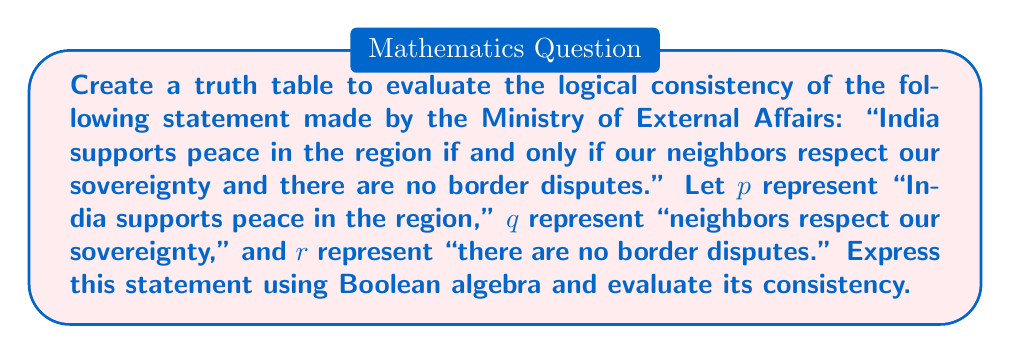Could you help me with this problem? 1. First, let's express the statement using Boolean algebra:
   $p \leftrightarrow (q \land r)$

2. To create a truth table, we need to consider all possible combinations of truth values for $p$, $q$, and $r$. There are $2^3 = 8$ possible combinations.

3. Let's create the truth table:

   | $p$ | $q$ | $r$ | $q \land r$ | $p \leftrightarrow (q \land r)$ |
   |-----|-----|-----|-------------|--------------------------------|
   | 0   | 0   | 0   | 0           | 1                              |
   | 0   | 0   | 1   | 0           | 1                              |
   | 0   | 1   | 0   | 0           | 1                              |
   | 0   | 1   | 1   | 1           | 0                              |
   | 1   | 0   | 0   | 0           | 0                              |
   | 1   | 0   | 1   | 0           | 0                              |
   | 1   | 1   | 0   | 0           | 0                              |
   | 1   | 1   | 1   | 1           | 1                              |

4. To evaluate logical consistency, we need to check if there's at least one row where the final column is true (1).

5. We can see that there are multiple rows where the final column is 1, specifically when:
   a) $p = 0$, $q = 0$, $r = 0$
   b) $p = 0$, $q = 0$, $r = 1$
   c) $p = 0$, $q = 1$, $r = 0$
   d) $p = 1$, $q = 1$, $r = 1$

6. Since there exists at least one combination of truth values that makes the statement true, the statement is logically consistent.
Answer: Logically consistent 